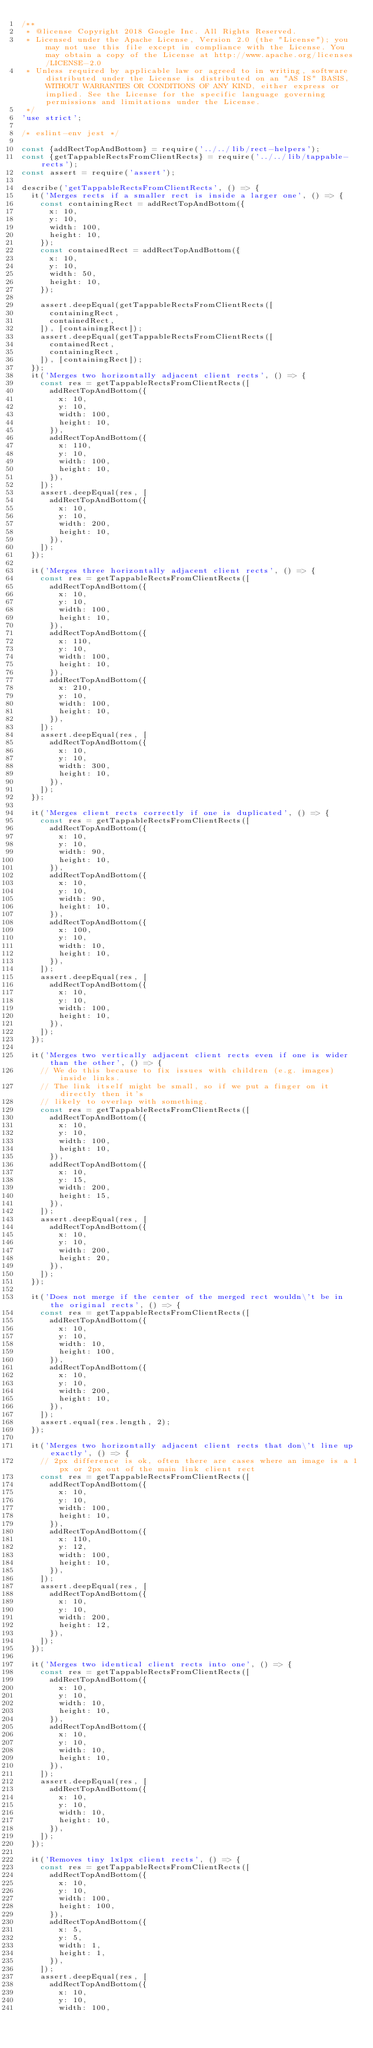Convert code to text. <code><loc_0><loc_0><loc_500><loc_500><_JavaScript_>/**
 * @license Copyright 2018 Google Inc. All Rights Reserved.
 * Licensed under the Apache License, Version 2.0 (the "License"); you may not use this file except in compliance with the License. You may obtain a copy of the License at http://www.apache.org/licenses/LICENSE-2.0
 * Unless required by applicable law or agreed to in writing, software distributed under the License is distributed on an "AS IS" BASIS, WITHOUT WARRANTIES OR CONDITIONS OF ANY KIND, either express or implied. See the License for the specific language governing permissions and limitations under the License.
 */
'use strict';

/* eslint-env jest */

const {addRectTopAndBottom} = require('../../lib/rect-helpers');
const {getTappableRectsFromClientRects} = require('../../lib/tappable-rects');
const assert = require('assert');

describe('getTappableRectsFromClientRects', () => {
  it('Merges rects if a smaller rect is inside a larger one', () => {
    const containingRect = addRectTopAndBottom({
      x: 10,
      y: 10,
      width: 100,
      height: 10,
    });
    const containedRect = addRectTopAndBottom({
      x: 10,
      y: 10,
      width: 50,
      height: 10,
    });

    assert.deepEqual(getTappableRectsFromClientRects([
      containingRect,
      containedRect,
    ]), [containingRect]);
    assert.deepEqual(getTappableRectsFromClientRects([
      containedRect,
      containingRect,
    ]), [containingRect]);
  });
  it('Merges two horizontally adjacent client rects', () => {
    const res = getTappableRectsFromClientRects([
      addRectTopAndBottom({
        x: 10,
        y: 10,
        width: 100,
        height: 10,
      }),
      addRectTopAndBottom({
        x: 110,
        y: 10,
        width: 100,
        height: 10,
      }),
    ]);
    assert.deepEqual(res, [
      addRectTopAndBottom({
        x: 10,
        y: 10,
        width: 200,
        height: 10,
      }),
    ]);
  });

  it('Merges three horizontally adjacent client rects', () => {
    const res = getTappableRectsFromClientRects([
      addRectTopAndBottom({
        x: 10,
        y: 10,
        width: 100,
        height: 10,
      }),
      addRectTopAndBottom({
        x: 110,
        y: 10,
        width: 100,
        height: 10,
      }),
      addRectTopAndBottom({
        x: 210,
        y: 10,
        width: 100,
        height: 10,
      }),
    ]);
    assert.deepEqual(res, [
      addRectTopAndBottom({
        x: 10,
        y: 10,
        width: 300,
        height: 10,
      }),
    ]);
  });

  it('Merges client rects correctly if one is duplicated', () => {
    const res = getTappableRectsFromClientRects([
      addRectTopAndBottom({
        x: 10,
        y: 10,
        width: 90,
        height: 10,
      }),
      addRectTopAndBottom({
        x: 10,
        y: 10,
        width: 90,
        height: 10,
      }),
      addRectTopAndBottom({
        x: 100,
        y: 10,
        width: 10,
        height: 10,
      }),
    ]);
    assert.deepEqual(res, [
      addRectTopAndBottom({
        x: 10,
        y: 10,
        width: 100,
        height: 10,
      }),
    ]);
  });

  it('Merges two vertically adjacent client rects even if one is wider than the other', () => {
    // We do this because to fix issues with children (e.g. images) inside links.
    // The link itself might be small, so if we put a finger on it directly then it's
    // likely to overlap with something.
    const res = getTappableRectsFromClientRects([
      addRectTopAndBottom({
        x: 10,
        y: 10,
        width: 100,
        height: 10,
      }),
      addRectTopAndBottom({
        x: 10,
        y: 15,
        width: 200,
        height: 15,
      }),
    ]);
    assert.deepEqual(res, [
      addRectTopAndBottom({
        x: 10,
        y: 10,
        width: 200,
        height: 20,
      }),
    ]);
  });

  it('Does not merge if the center of the merged rect wouldn\'t be in the original rects', () => {
    const res = getTappableRectsFromClientRects([
      addRectTopAndBottom({
        x: 10,
        y: 10,
        width: 10,
        height: 100,
      }),
      addRectTopAndBottom({
        x: 10,
        y: 10,
        width: 200,
        height: 10,
      }),
    ]);
    assert.equal(res.length, 2);
  });

  it('Merges two horizontally adjacent client rects that don\'t line up exactly', () => {
    // 2px difference is ok, often there are cases where an image is a 1px or 2px out of the main link client rect
    const res = getTappableRectsFromClientRects([
      addRectTopAndBottom({
        x: 10,
        y: 10,
        width: 100,
        height: 10,
      }),
      addRectTopAndBottom({
        x: 110,
        y: 12,
        width: 100,
        height: 10,
      }),
    ]);
    assert.deepEqual(res, [
      addRectTopAndBottom({
        x: 10,
        y: 10,
        width: 200,
        height: 12,
      }),
    ]);
  });

  it('Merges two identical client rects into one', () => {
    const res = getTappableRectsFromClientRects([
      addRectTopAndBottom({
        x: 10,
        y: 10,
        width: 10,
        height: 10,
      }),
      addRectTopAndBottom({
        x: 10,
        y: 10,
        width: 10,
        height: 10,
      }),
    ]);
    assert.deepEqual(res, [
      addRectTopAndBottom({
        x: 10,
        y: 10,
        width: 10,
        height: 10,
      }),
    ]);
  });

  it('Removes tiny 1x1px client rects', () => {
    const res = getTappableRectsFromClientRects([
      addRectTopAndBottom({
        x: 10,
        y: 10,
        width: 100,
        height: 100,
      }),
      addRectTopAndBottom({
        x: 5,
        y: 5,
        width: 1,
        height: 1,
      }),
    ]);
    assert.deepEqual(res, [
      addRectTopAndBottom({
        x: 10,
        y: 10,
        width: 100,</code> 